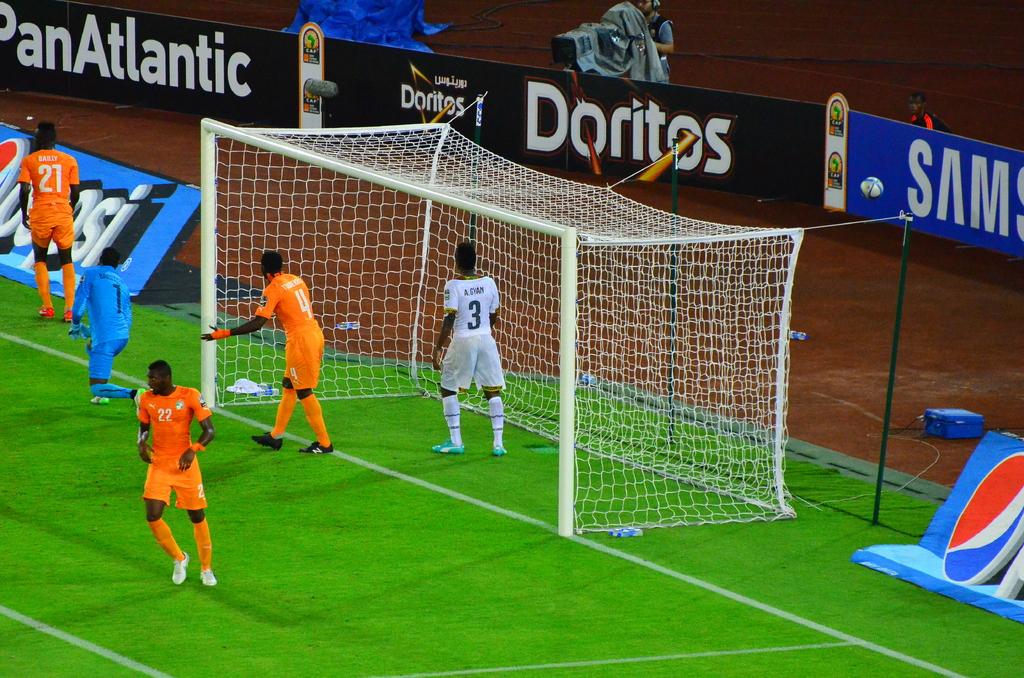Is this a passport photo?
Provide a succinct answer. Answering does not require reading text in the image. Who is the middle sponsor?
Your response must be concise. Doritos. 